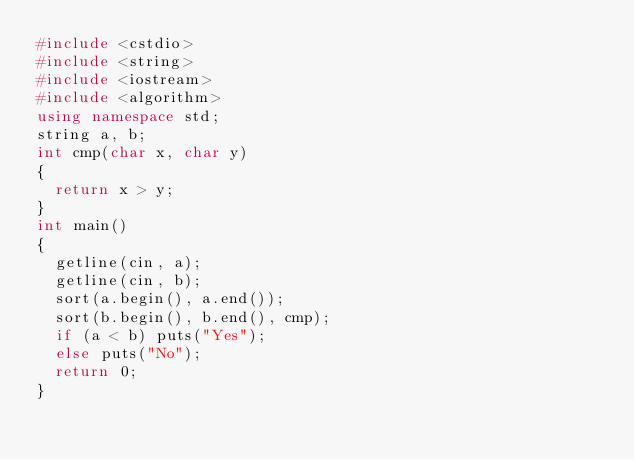Convert code to text. <code><loc_0><loc_0><loc_500><loc_500><_C++_>#include <cstdio>
#include <string>
#include <iostream>
#include <algorithm>
using namespace std;
string a, b;
int cmp(char x, char y)
{
	return x > y;
}
int main()
{
	getline(cin, a);
	getline(cin, b);
	sort(a.begin(), a.end());
	sort(b.begin(), b.end(), cmp);
	if (a < b) puts("Yes");
	else puts("No");
	return 0;
}</code> 